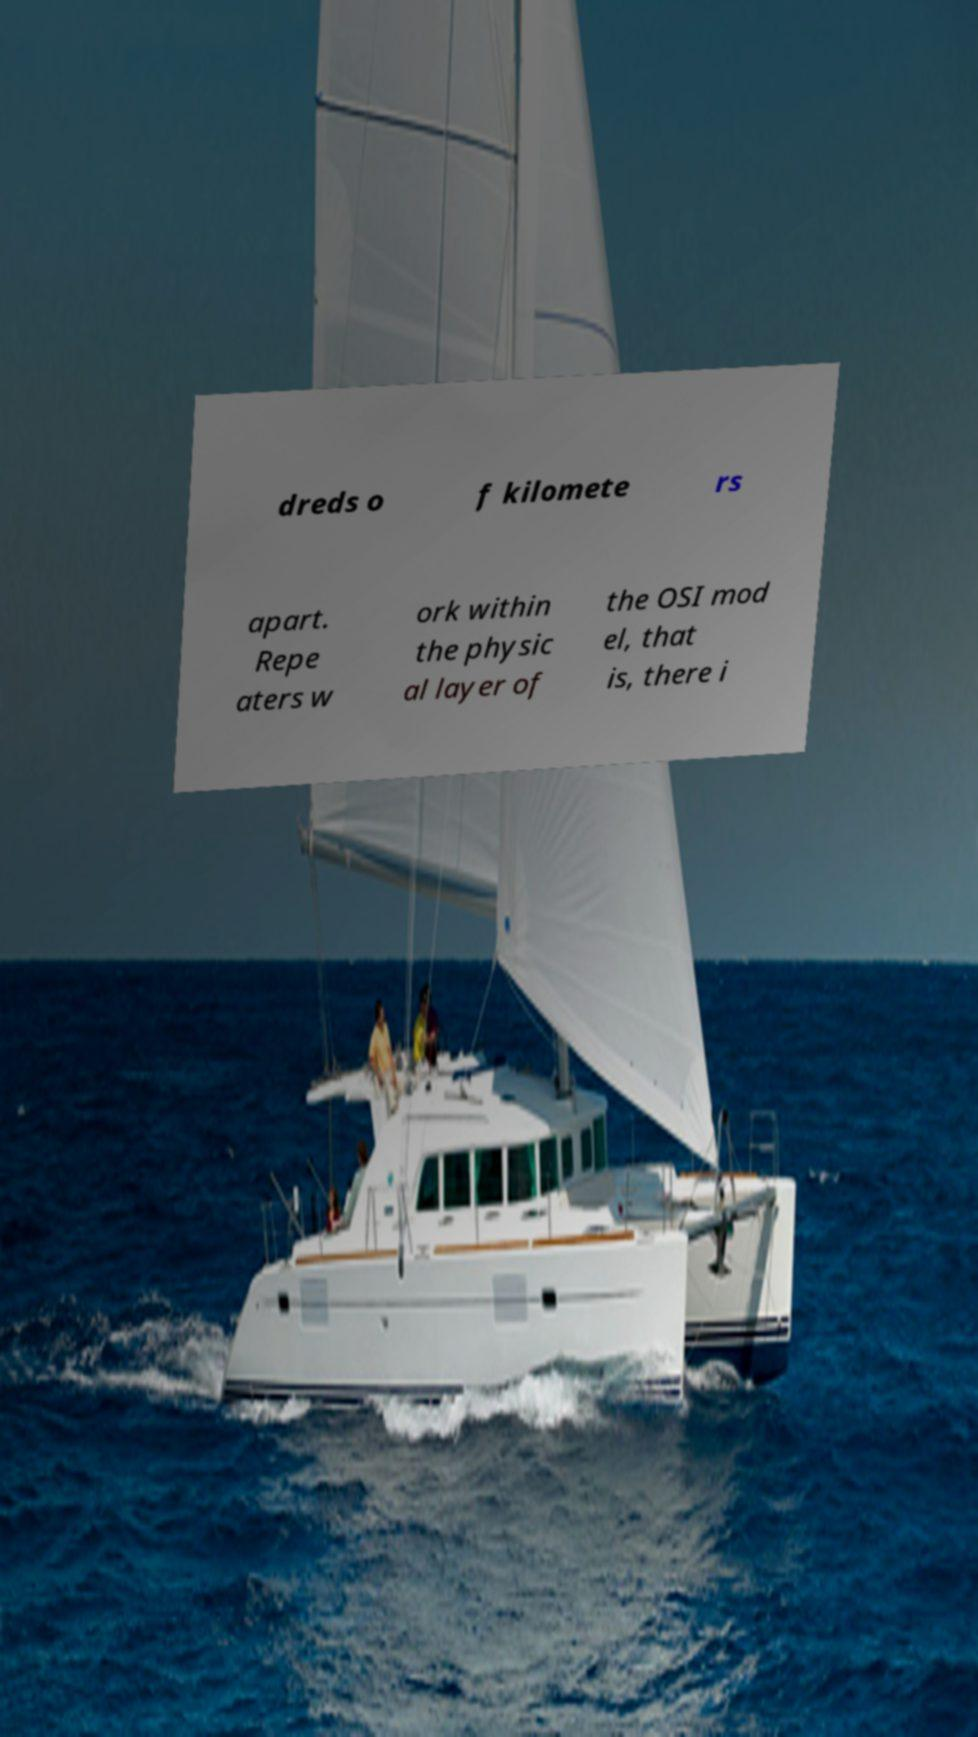What messages or text are displayed in this image? I need them in a readable, typed format. dreds o f kilomete rs apart. Repe aters w ork within the physic al layer of the OSI mod el, that is, there i 